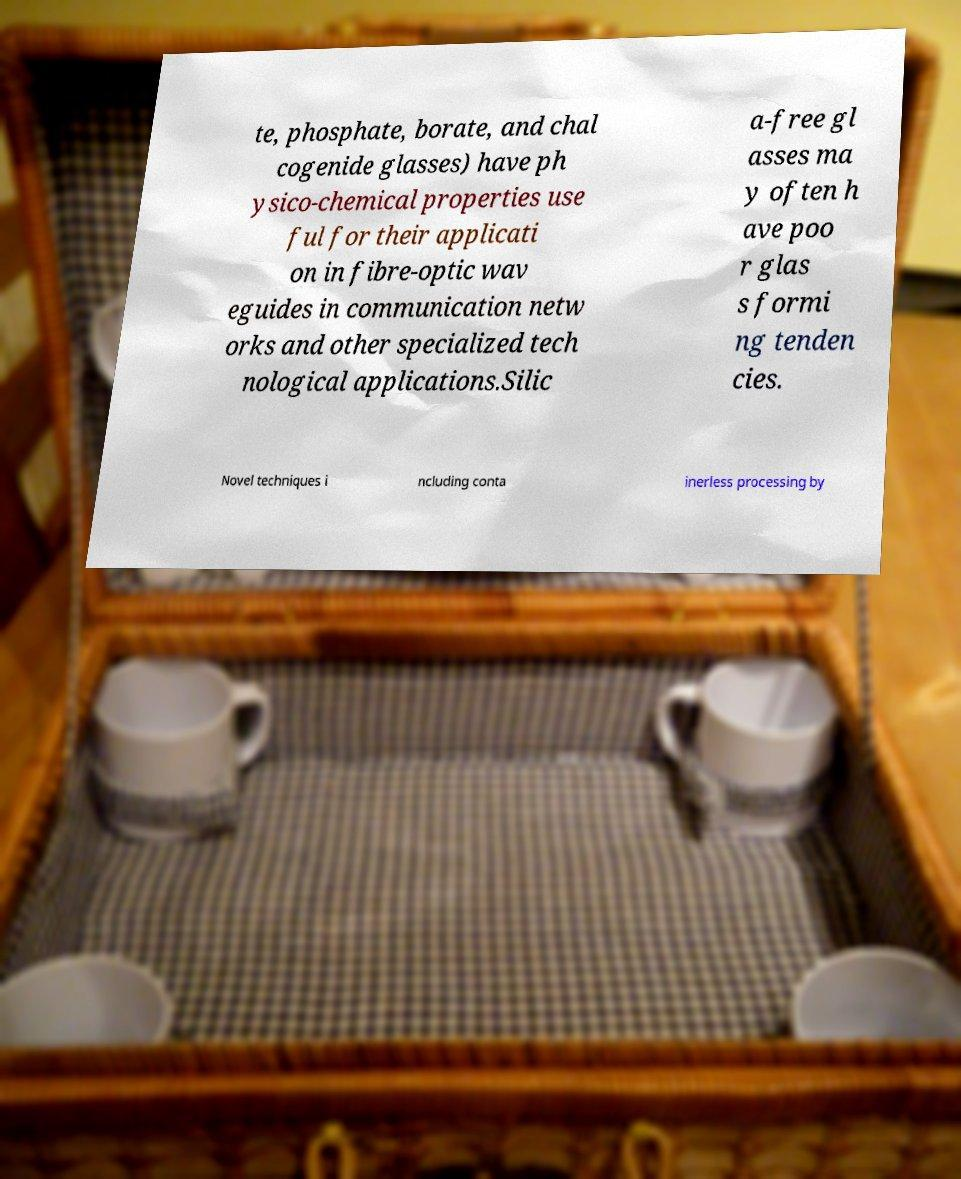Can you accurately transcribe the text from the provided image for me? te, phosphate, borate, and chal cogenide glasses) have ph ysico-chemical properties use ful for their applicati on in fibre-optic wav eguides in communication netw orks and other specialized tech nological applications.Silic a-free gl asses ma y often h ave poo r glas s formi ng tenden cies. Novel techniques i ncluding conta inerless processing by 